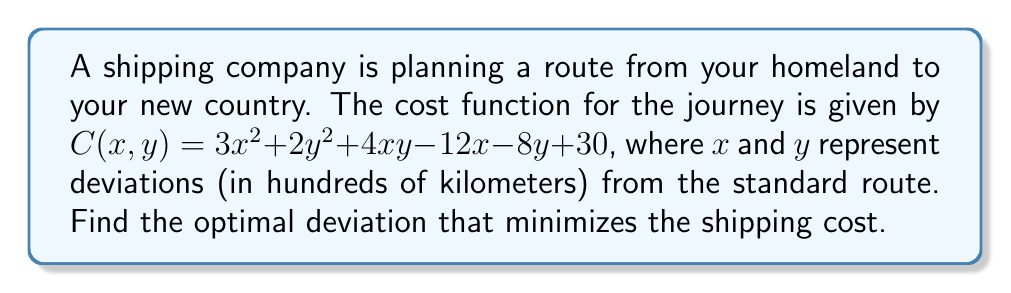Could you help me with this problem? 1) To find the minimum cost, we need to find the critical points of the cost function $C(x,y)$. These are the points where the partial derivatives of $C$ with respect to $x$ and $y$ are both zero.

2) Calculate the partial derivatives:
   $$\frac{\partial C}{\partial x} = 6x + 4y - 12$$
   $$\frac{\partial C}{\partial y} = 4x + 4y - 8$$

3) Set both partial derivatives to zero:
   $$6x + 4y - 12 = 0 \quad (1)$$
   $$4x + 4y - 8 = 0 \quad (2)$$

4) Solve this system of equations:
   From (2): $y = 2 - x$
   Substitute this into (1):
   $$6x + 4(2-x) - 12 = 0$$
   $$6x + 8 - 4x - 12 = 0$$
   $$2x - 4 = 0$$
   $$x = 2$$

5) Substitute $x = 2$ back into $y = 2 - x$:
   $$y = 2 - 2 = 0$$

6) Therefore, the critical point is (2, 0).

7) To confirm this is a minimum, we can check the second derivatives:
   $$\frac{\partial^2 C}{\partial x^2} = 6$$
   $$\frac{\partial^2 C}{\partial y^2} = 4$$
   $$\frac{\partial^2 C}{\partial x\partial y} = 4$$

   The Hessian matrix is:
   $$H = \begin{bmatrix} 6 & 4 \\ 4 & 4 \end{bmatrix}$$

   Since $\frac{\partial^2 C}{\partial x^2} > 0$ and $\det(H) = 24 - 16 = 8 > 0$, the critical point is indeed a minimum.
Answer: (2, 0) 